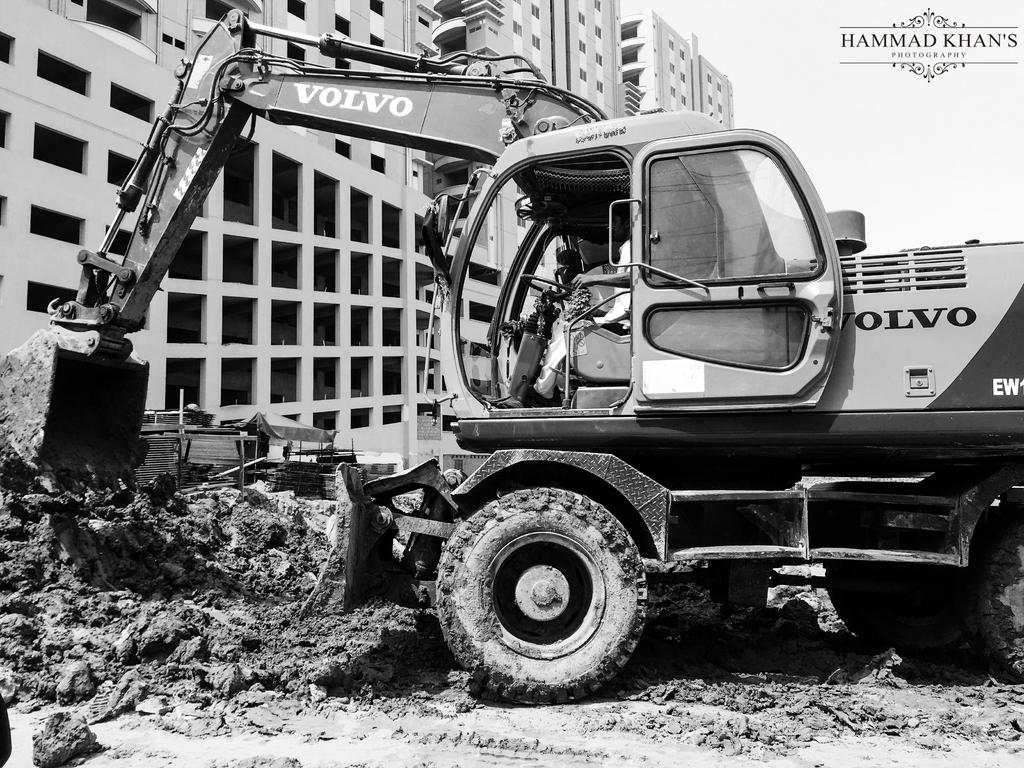What is the color scheme of the image? The image is black and white. What type of machinery is present in the image? There is a crane in the image. Who is operating the crane? A person is sitting in the crane. What type of terrain is visible in the image? There is mud visible in the image. What type of shelter is present in the image? There is a tent in the image. Where are the buildings located in the image? The buildings are located at the left side of the image. What time of day is it in the image, based on the position of the sun? The image is black and white, so it is not possible to determine the time of day based on the position of the sun. Are there any dinosaurs visible in the image? No, there are no dinosaurs present in the image. 